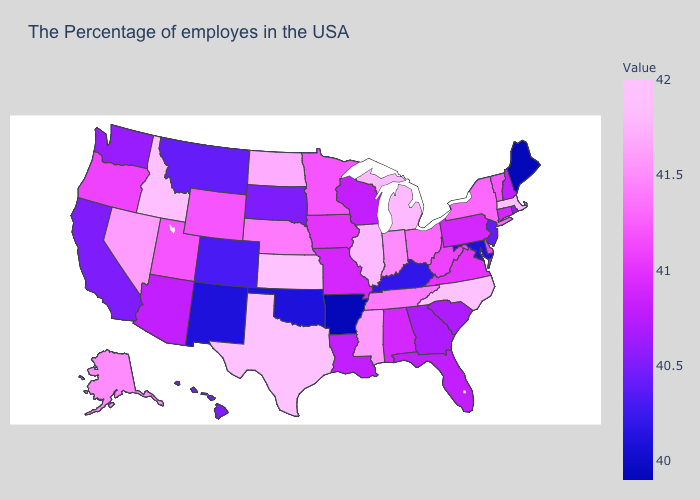Which states have the highest value in the USA?
Concise answer only. North Carolina, Kansas, Texas. 